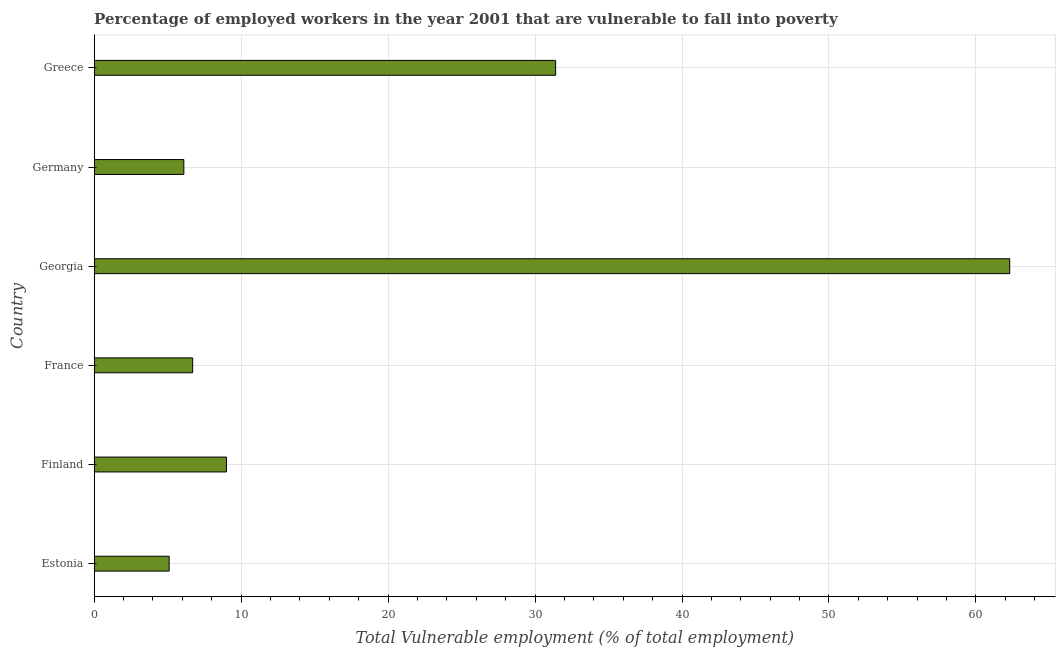Does the graph contain any zero values?
Your answer should be compact. No. Does the graph contain grids?
Offer a very short reply. Yes. What is the title of the graph?
Provide a short and direct response. Percentage of employed workers in the year 2001 that are vulnerable to fall into poverty. What is the label or title of the X-axis?
Keep it short and to the point. Total Vulnerable employment (% of total employment). What is the total vulnerable employment in Germany?
Keep it short and to the point. 6.1. Across all countries, what is the maximum total vulnerable employment?
Provide a short and direct response. 62.3. Across all countries, what is the minimum total vulnerable employment?
Offer a very short reply. 5.1. In which country was the total vulnerable employment maximum?
Make the answer very short. Georgia. In which country was the total vulnerable employment minimum?
Provide a succinct answer. Estonia. What is the sum of the total vulnerable employment?
Your answer should be very brief. 120.6. What is the average total vulnerable employment per country?
Keep it short and to the point. 20.1. What is the median total vulnerable employment?
Keep it short and to the point. 7.85. What is the ratio of the total vulnerable employment in Georgia to that in Greece?
Your answer should be compact. 1.98. What is the difference between the highest and the second highest total vulnerable employment?
Your answer should be compact. 30.9. What is the difference between the highest and the lowest total vulnerable employment?
Give a very brief answer. 57.2. How many countries are there in the graph?
Keep it short and to the point. 6. Are the values on the major ticks of X-axis written in scientific E-notation?
Keep it short and to the point. No. What is the Total Vulnerable employment (% of total employment) of Estonia?
Your response must be concise. 5.1. What is the Total Vulnerable employment (% of total employment) of France?
Give a very brief answer. 6.7. What is the Total Vulnerable employment (% of total employment) in Georgia?
Provide a short and direct response. 62.3. What is the Total Vulnerable employment (% of total employment) of Germany?
Give a very brief answer. 6.1. What is the Total Vulnerable employment (% of total employment) in Greece?
Give a very brief answer. 31.4. What is the difference between the Total Vulnerable employment (% of total employment) in Estonia and Finland?
Your answer should be compact. -3.9. What is the difference between the Total Vulnerable employment (% of total employment) in Estonia and France?
Ensure brevity in your answer.  -1.6. What is the difference between the Total Vulnerable employment (% of total employment) in Estonia and Georgia?
Give a very brief answer. -57.2. What is the difference between the Total Vulnerable employment (% of total employment) in Estonia and Greece?
Provide a succinct answer. -26.3. What is the difference between the Total Vulnerable employment (% of total employment) in Finland and France?
Your response must be concise. 2.3. What is the difference between the Total Vulnerable employment (% of total employment) in Finland and Georgia?
Ensure brevity in your answer.  -53.3. What is the difference between the Total Vulnerable employment (% of total employment) in Finland and Greece?
Your response must be concise. -22.4. What is the difference between the Total Vulnerable employment (% of total employment) in France and Georgia?
Ensure brevity in your answer.  -55.6. What is the difference between the Total Vulnerable employment (% of total employment) in France and Greece?
Make the answer very short. -24.7. What is the difference between the Total Vulnerable employment (% of total employment) in Georgia and Germany?
Your answer should be compact. 56.2. What is the difference between the Total Vulnerable employment (% of total employment) in Georgia and Greece?
Make the answer very short. 30.9. What is the difference between the Total Vulnerable employment (% of total employment) in Germany and Greece?
Your answer should be very brief. -25.3. What is the ratio of the Total Vulnerable employment (% of total employment) in Estonia to that in Finland?
Provide a short and direct response. 0.57. What is the ratio of the Total Vulnerable employment (% of total employment) in Estonia to that in France?
Give a very brief answer. 0.76. What is the ratio of the Total Vulnerable employment (% of total employment) in Estonia to that in Georgia?
Your response must be concise. 0.08. What is the ratio of the Total Vulnerable employment (% of total employment) in Estonia to that in Germany?
Provide a succinct answer. 0.84. What is the ratio of the Total Vulnerable employment (% of total employment) in Estonia to that in Greece?
Make the answer very short. 0.16. What is the ratio of the Total Vulnerable employment (% of total employment) in Finland to that in France?
Your answer should be very brief. 1.34. What is the ratio of the Total Vulnerable employment (% of total employment) in Finland to that in Georgia?
Give a very brief answer. 0.14. What is the ratio of the Total Vulnerable employment (% of total employment) in Finland to that in Germany?
Your answer should be very brief. 1.48. What is the ratio of the Total Vulnerable employment (% of total employment) in Finland to that in Greece?
Offer a terse response. 0.29. What is the ratio of the Total Vulnerable employment (% of total employment) in France to that in Georgia?
Provide a succinct answer. 0.11. What is the ratio of the Total Vulnerable employment (% of total employment) in France to that in Germany?
Make the answer very short. 1.1. What is the ratio of the Total Vulnerable employment (% of total employment) in France to that in Greece?
Provide a short and direct response. 0.21. What is the ratio of the Total Vulnerable employment (% of total employment) in Georgia to that in Germany?
Provide a succinct answer. 10.21. What is the ratio of the Total Vulnerable employment (% of total employment) in Georgia to that in Greece?
Your answer should be compact. 1.98. What is the ratio of the Total Vulnerable employment (% of total employment) in Germany to that in Greece?
Your answer should be very brief. 0.19. 